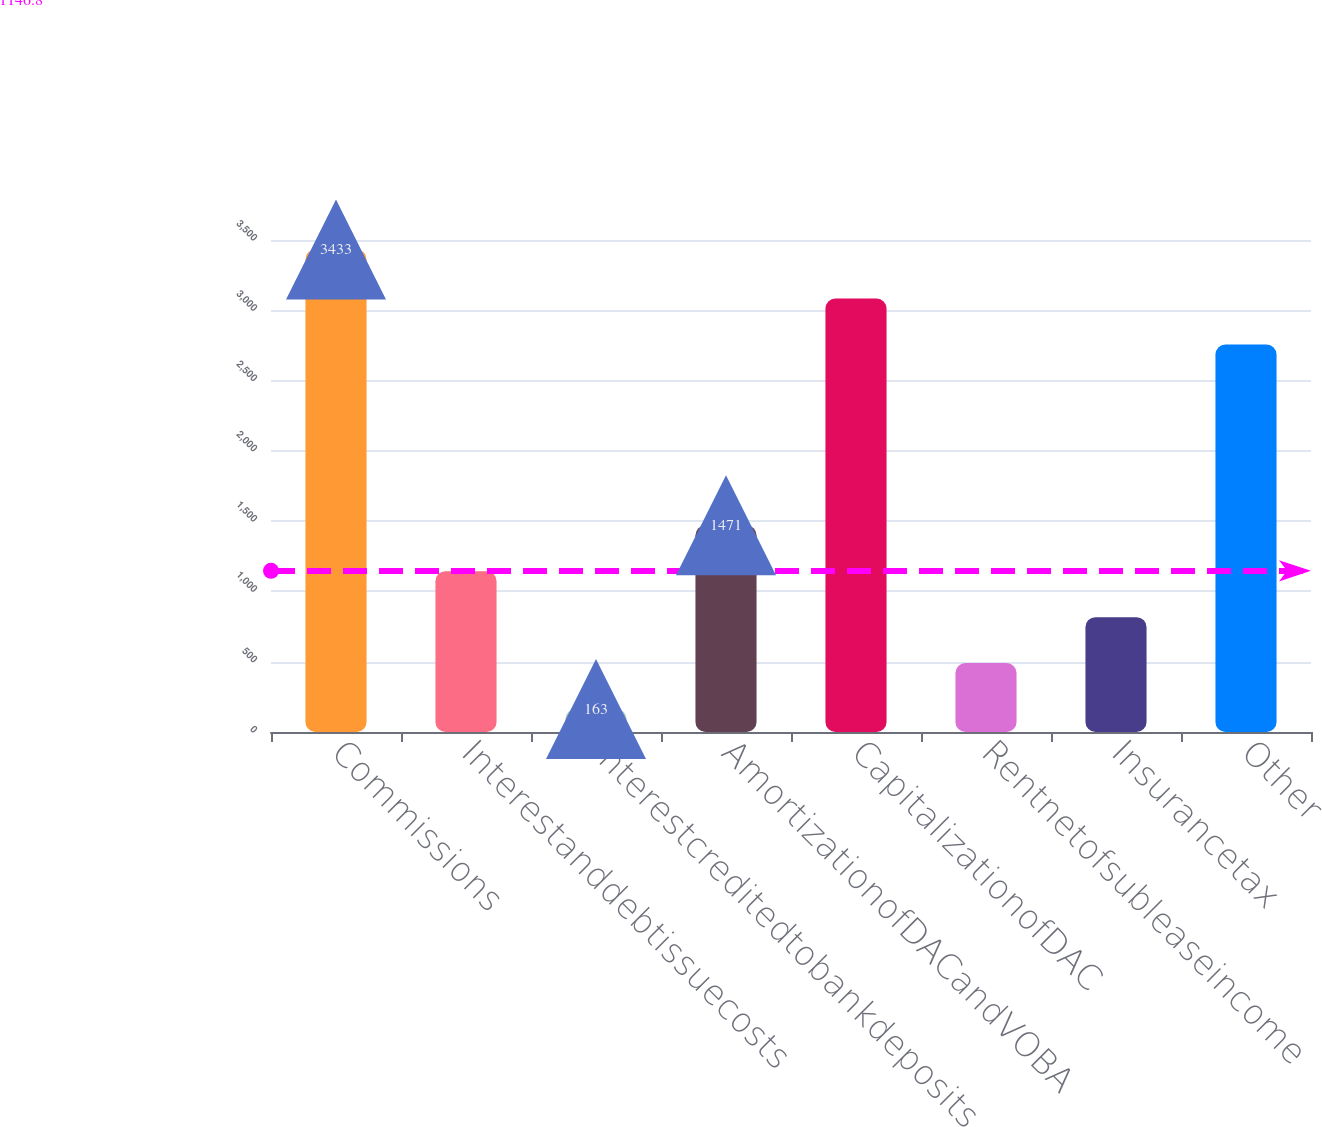Convert chart. <chart><loc_0><loc_0><loc_500><loc_500><bar_chart><fcel>Commissions<fcel>Interestanddebtissuecosts<fcel>Interestcreditedtobankdeposits<fcel>AmortizationofDACandVOBA<fcel>CapitalizationofDAC<fcel>Rentnetofsubleaseincome<fcel>Insurancetax<fcel>Other<nl><fcel>3433<fcel>1144<fcel>163<fcel>1471<fcel>3083<fcel>490<fcel>817<fcel>2756<nl></chart> 